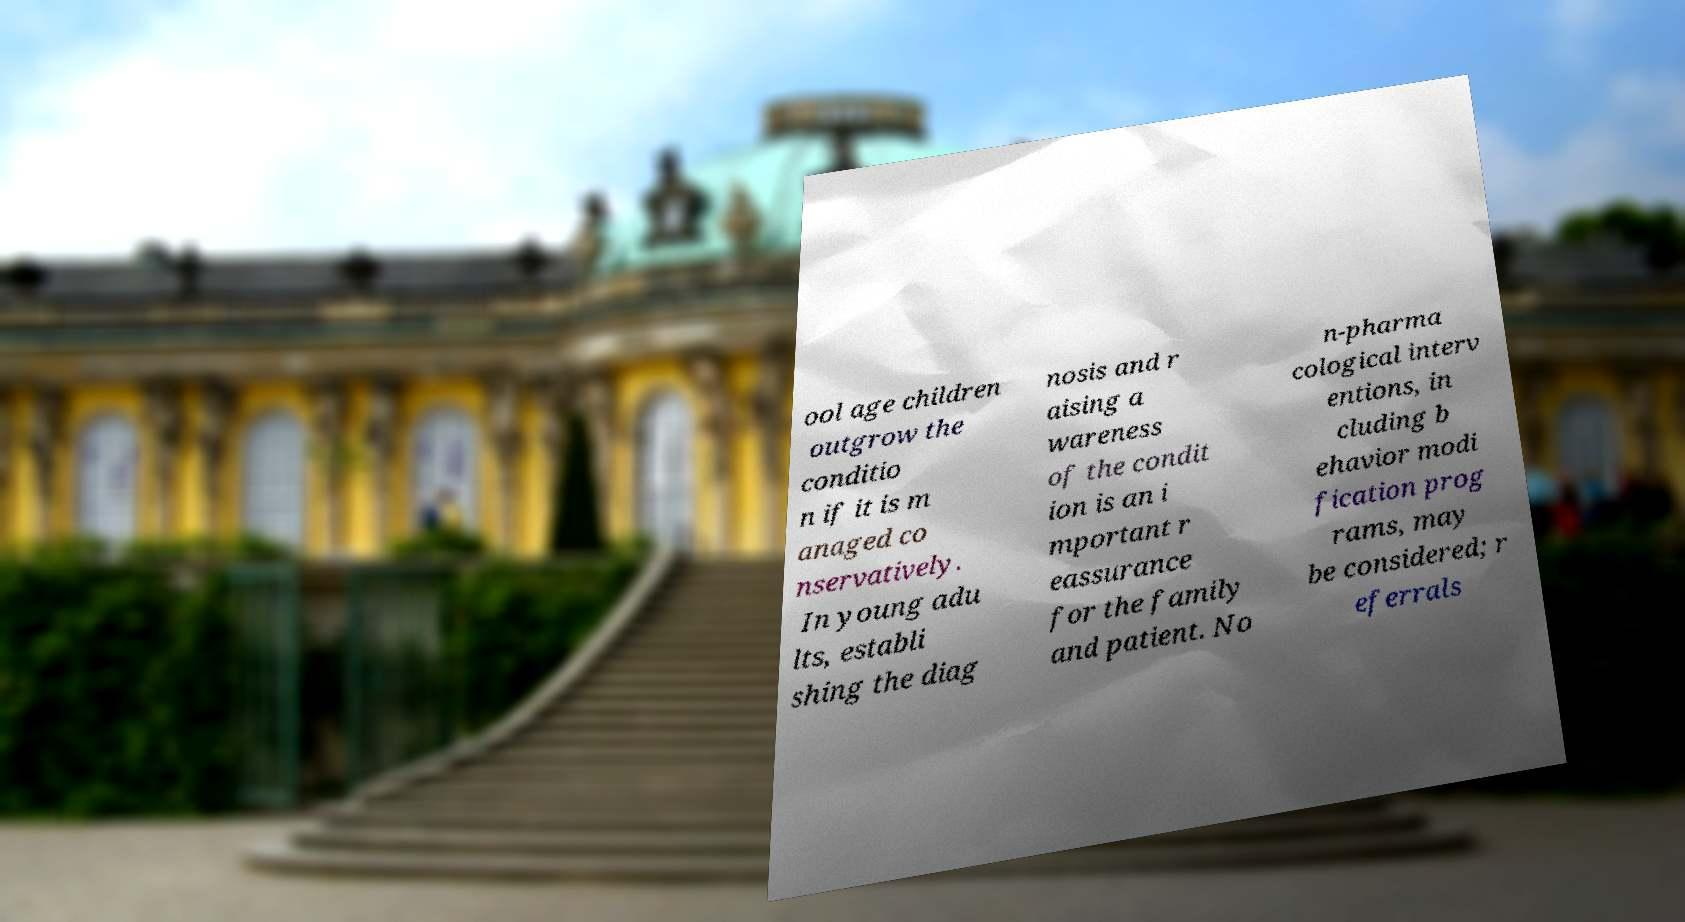There's text embedded in this image that I need extracted. Can you transcribe it verbatim? ool age children outgrow the conditio n if it is m anaged co nservatively. In young adu lts, establi shing the diag nosis and r aising a wareness of the condit ion is an i mportant r eassurance for the family and patient. No n-pharma cological interv entions, in cluding b ehavior modi fication prog rams, may be considered; r eferrals 